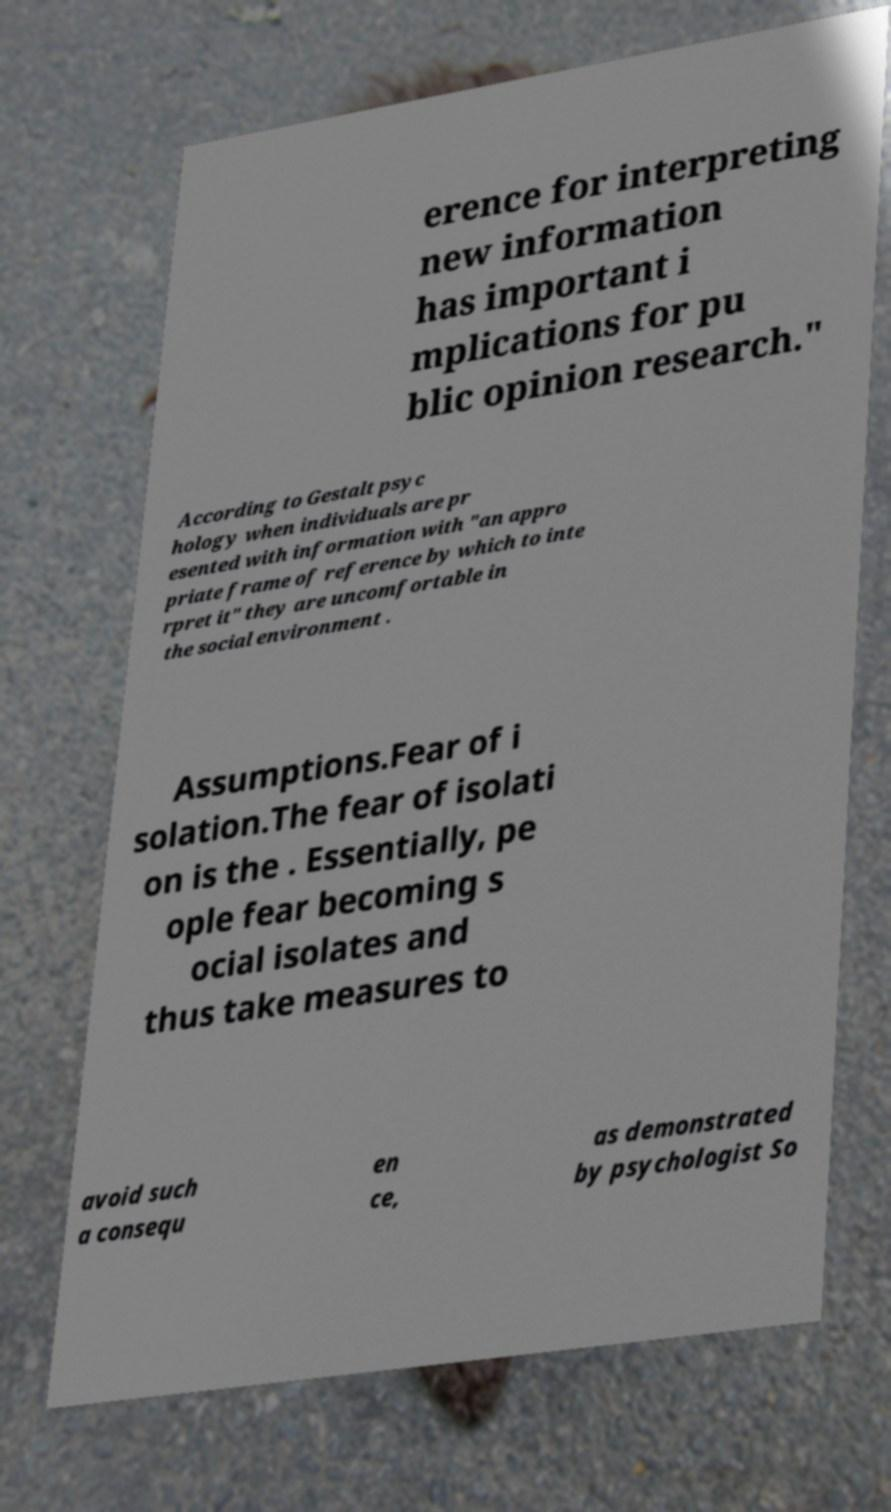I need the written content from this picture converted into text. Can you do that? erence for interpreting new information has important i mplications for pu blic opinion research." According to Gestalt psyc hology when individuals are pr esented with information with "an appro priate frame of reference by which to inte rpret it" they are uncomfortable in the social environment . Assumptions.Fear of i solation.The fear of isolati on is the . Essentially, pe ople fear becoming s ocial isolates and thus take measures to avoid such a consequ en ce, as demonstrated by psychologist So 